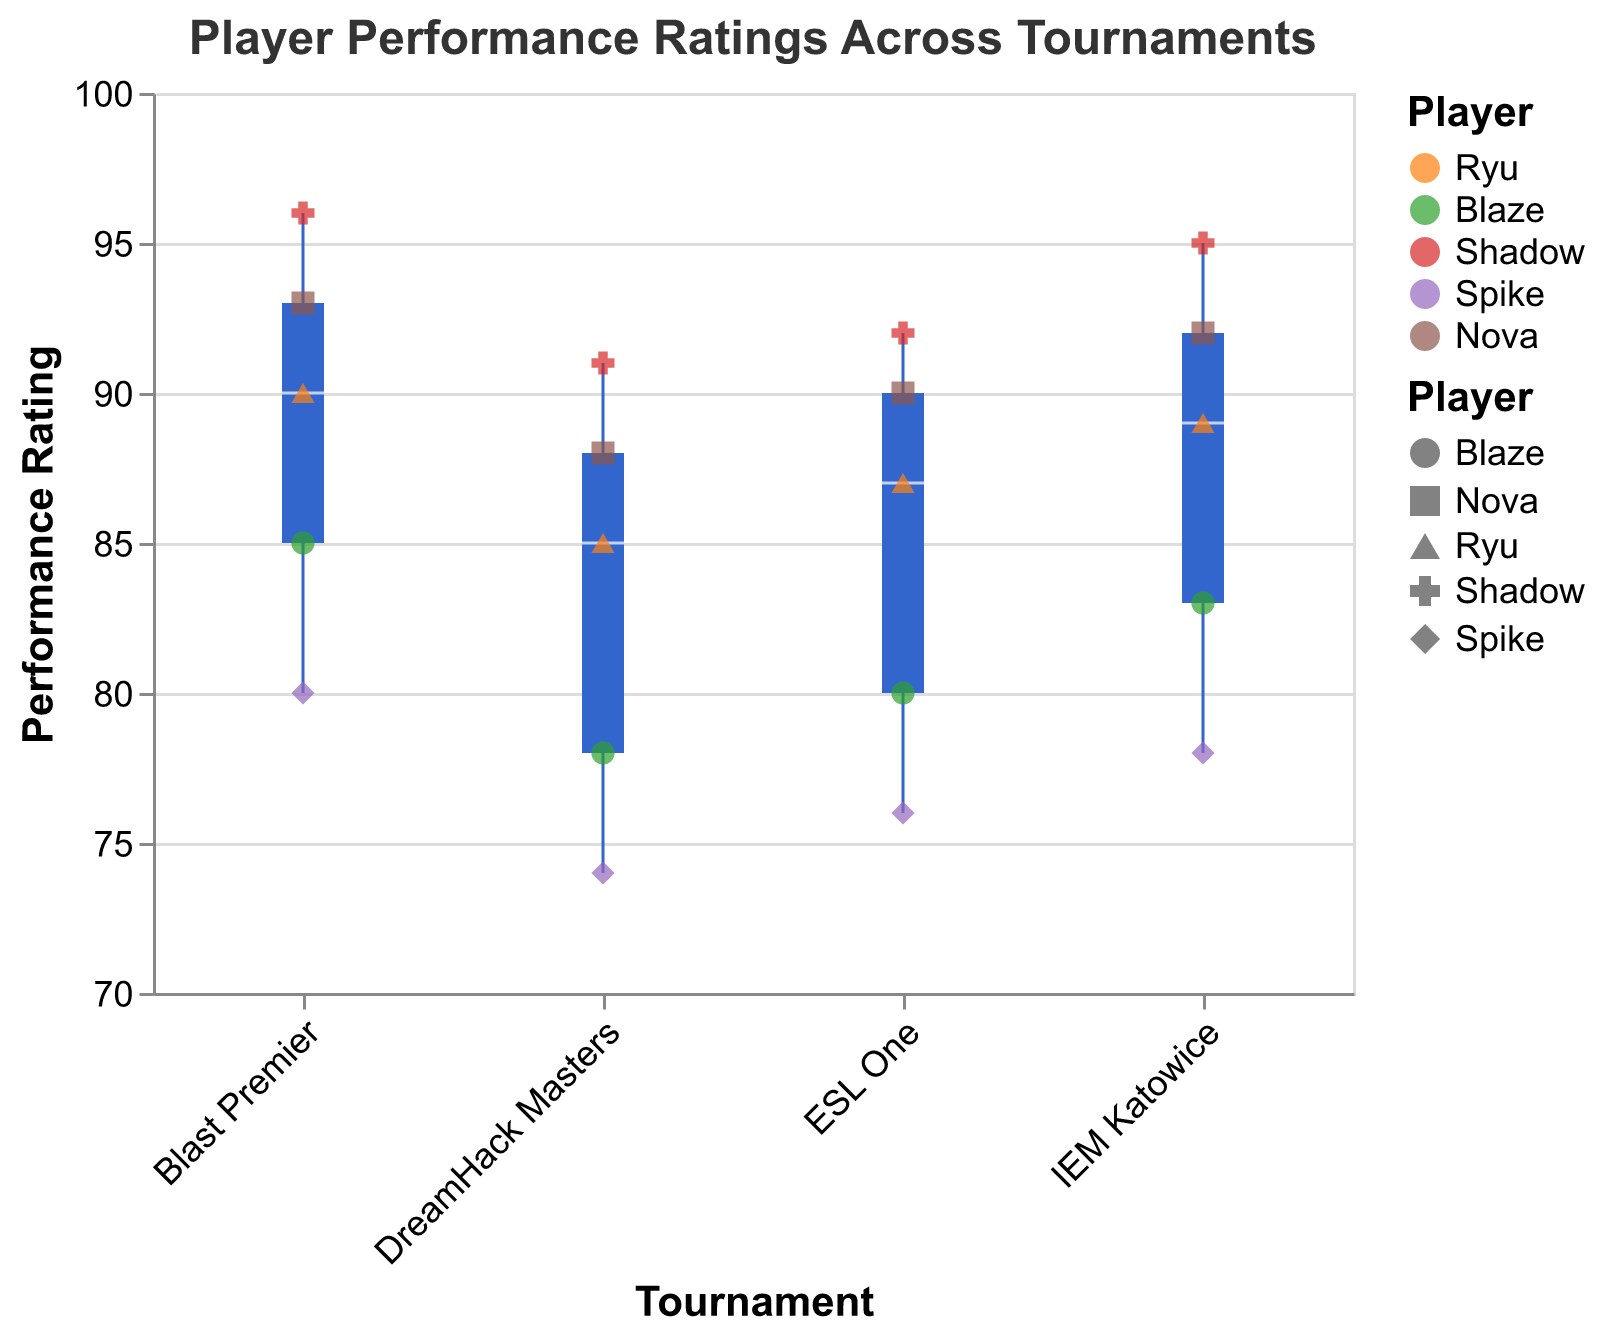How many players participated in each tournament? Each tournament's box plot represents a range of performance ratings, and for each tournament, there are 5 scatter points corresponding to 5 players' ratings.
Answer: 5 What is the median performance rating for Shadow across all tournaments? Observe the color-coded points for Shadow in each tournament and read the performance ratings: DreamHack Masters (91), ESL One (92), IEM Katowice (95), and Blast Premier (96). The median is calculated by sorting these values in ascending order (91, 92, 95, 96) and finding the middle value.
Answer: 93.5 Which tournament has the highest median performance rating? Look at the box plots and their median lines in the center. The tournament with the highest median line is the Blast Premier.
Answer: Blast Premier What is the performance rating range for Blaze in Blast Premier? Find the scatter point color and shape corresponding to Blaze in the Blast Premier section. The performance rating given is 85. Since it's a single data point, the range is just 85.
Answer: 85 Who had the lowest performance rating in DreamHack Masters? In DreamHack Masters, check the lowest scatter point visually. The lowest rating scatter point is Spike with a rating of 74.
Answer: Spike How does the interquartile range (IQR) of performance ratings compare between IEM Katowice and ESL One? The IQR of a box plot represents the middle 50% of the data. For IEM Katowice, the IQR appears larger because the box plot is visually wider along the y-axis compared to the IQR of ESL One.
Answer: IEM Katowice > ESL One What is the average performance rating of Ryu across all tournaments? Sum Ryu's ratings (85 + 87 + 89 + 90) and divide by the number of tournaments (4): (85 + 87 + 89 + 90) / 4 = 87.75
Answer: 87.75 Compare the highest performance ratings for Nova in DreamHack Masters and Blast Premier. Identify the performance ratings for Nova in DreamHack Masters (88) and Blast Premier (93). The highest rating is in Blast Premier.
Answer: Blast Premier Does Spike's performance trend upward, downward, or stay consistent across the tournaments? Track Spike's ratings: DreamHack Masters (74), ESL One (76), IEM Katowice (78), Blast Premier (80). Spike’s ratings show an upward trend.
Answer: Upward Which player has the most consistent performance across tournaments, based on their scatter points? Identify the player whose scatter points show the least variability. By comparing the evenly spaced scatter points, Ryu's ratings (85, 87, 89, 90) suggest consistency.
Answer: Ryu 